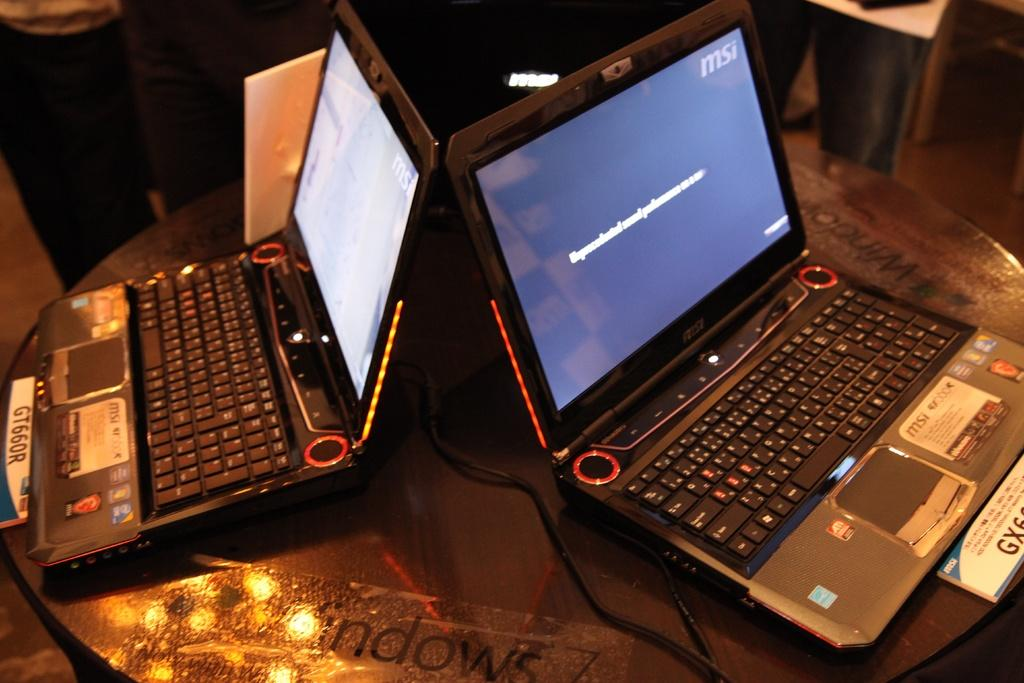<image>
Share a concise interpretation of the image provided. GT66OR is visible in front of the laptop on the left. 